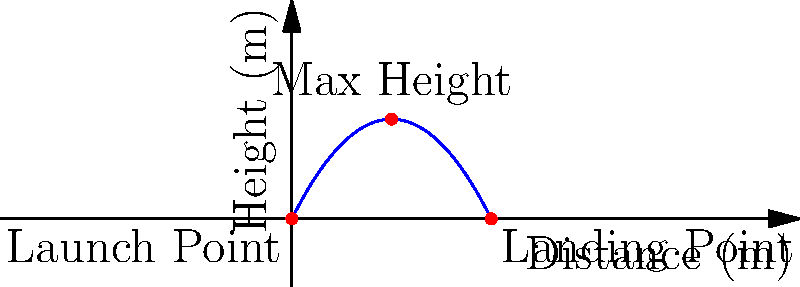As an aspiring lawyer, you're preparing a case involving a projectile motion incident. The trajectory of the object is shown in the graph above. If the initial velocity of the projectile is 10 m/s, what was the launch angle $\theta$ (in degrees) of the projectile? To solve this problem, we'll use the properties of projectile motion and the given information:

1) The range (horizontal distance) of the projectile is 8 meters.
2) The maximum height reached is 4 meters.
3) The initial velocity is 10 m/s.

Step 1: Use the range equation:
$R = \frac{v_0^2 \sin(2\theta)}{g}$

Where $R$ is the range (8 m), $v_0$ is the initial velocity (10 m/s), and $g$ is the acceleration due to gravity (9.8 m/s²).

Step 2: Substitute the known values:
$8 = \frac{10^2 \sin(2\theta)}{9.8}$

Step 3: Solve for $\sin(2\theta)$:
$\sin(2\theta) = \frac{8 \cdot 9.8}{100} = 0.784$

Step 4: Take the inverse sine (arcsin) of both sides:
$2\theta = \arcsin(0.784) = 51.68°$

Step 5: Solve for $\theta$:
$\theta = 51.68° / 2 = 25.84°$

We can verify this using the maximum height equation:
$h_{max} = \frac{v_0^2 \sin^2(\theta)}{2g}$

Substituting our values:
$4 = \frac{10^2 \sin^2(25.84°)}{2 \cdot 9.8}$

This equation checks out, confirming our solution.
Answer: $25.84°$ 